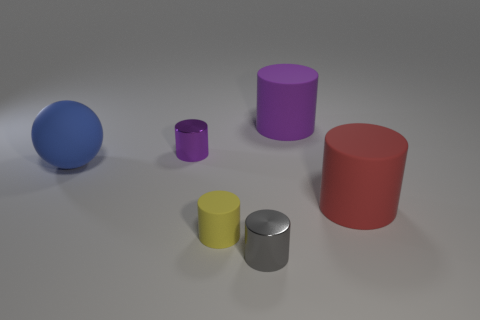Subtract all gray cylinders. How many cylinders are left? 4 Subtract all blue cylinders. Subtract all red spheres. How many cylinders are left? 5 Add 2 large blue things. How many objects exist? 8 Subtract all balls. How many objects are left? 5 Subtract 0 green cylinders. How many objects are left? 6 Subtract all yellow objects. Subtract all spheres. How many objects are left? 4 Add 6 large objects. How many large objects are left? 9 Add 5 blocks. How many blocks exist? 5 